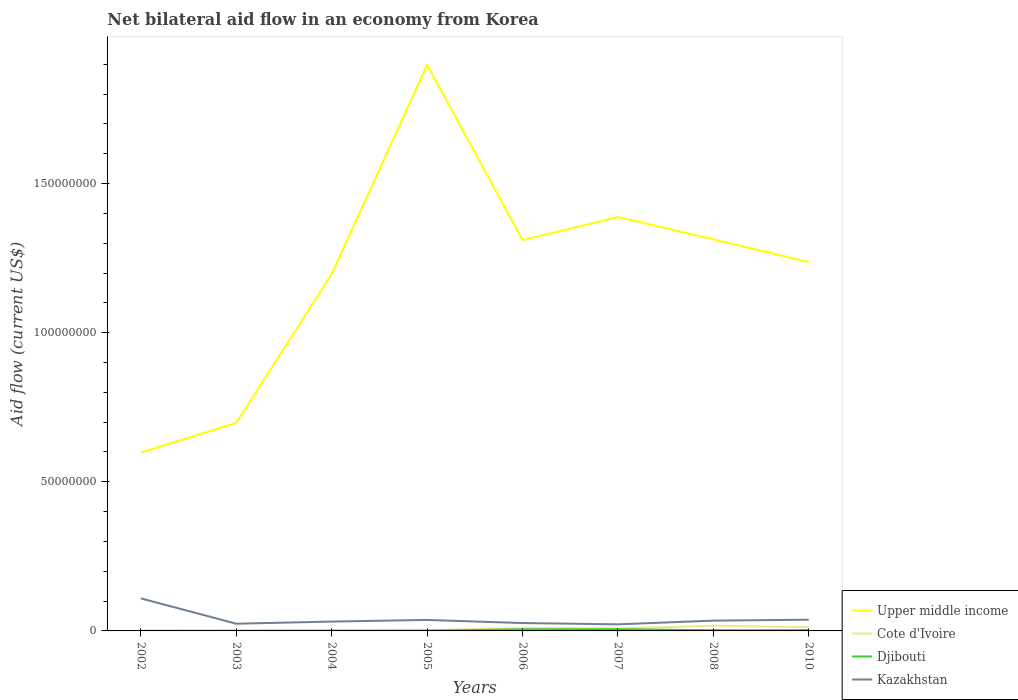Is the number of lines equal to the number of legend labels?
Make the answer very short. Yes. Across all years, what is the maximum net bilateral aid flow in Kazakhstan?
Your answer should be compact. 2.21e+06. In which year was the net bilateral aid flow in Djibouti maximum?
Provide a short and direct response. 2002. What is the total net bilateral aid flow in Djibouti in the graph?
Your answer should be compact. -4.30e+05. What is the difference between the highest and the second highest net bilateral aid flow in Cote d'Ivoire?
Ensure brevity in your answer.  1.72e+06. How many lines are there?
Your answer should be compact. 4. Does the graph contain any zero values?
Offer a very short reply. No. How many legend labels are there?
Provide a succinct answer. 4. How are the legend labels stacked?
Ensure brevity in your answer.  Vertical. What is the title of the graph?
Your answer should be compact. Net bilateral aid flow in an economy from Korea. Does "Isle of Man" appear as one of the legend labels in the graph?
Provide a succinct answer. No. What is the label or title of the Y-axis?
Your answer should be very brief. Aid flow (current US$). What is the Aid flow (current US$) in Upper middle income in 2002?
Keep it short and to the point. 5.98e+07. What is the Aid flow (current US$) of Djibouti in 2002?
Offer a terse response. 4.00e+04. What is the Aid flow (current US$) in Kazakhstan in 2002?
Ensure brevity in your answer.  1.09e+07. What is the Aid flow (current US$) of Upper middle income in 2003?
Give a very brief answer. 6.98e+07. What is the Aid flow (current US$) of Cote d'Ivoire in 2003?
Ensure brevity in your answer.  1.30e+05. What is the Aid flow (current US$) in Kazakhstan in 2003?
Make the answer very short. 2.42e+06. What is the Aid flow (current US$) in Upper middle income in 2004?
Make the answer very short. 1.20e+08. What is the Aid flow (current US$) of Djibouti in 2004?
Provide a short and direct response. 9.00e+04. What is the Aid flow (current US$) in Kazakhstan in 2004?
Your answer should be very brief. 3.13e+06. What is the Aid flow (current US$) of Upper middle income in 2005?
Your answer should be compact. 1.90e+08. What is the Aid flow (current US$) in Kazakhstan in 2005?
Provide a succinct answer. 3.68e+06. What is the Aid flow (current US$) of Upper middle income in 2006?
Your answer should be compact. 1.31e+08. What is the Aid flow (current US$) of Cote d'Ivoire in 2006?
Make the answer very short. 1.03e+06. What is the Aid flow (current US$) in Djibouti in 2006?
Your response must be concise. 5.30e+05. What is the Aid flow (current US$) in Kazakhstan in 2006?
Make the answer very short. 2.64e+06. What is the Aid flow (current US$) of Upper middle income in 2007?
Make the answer very short. 1.39e+08. What is the Aid flow (current US$) in Cote d'Ivoire in 2007?
Provide a short and direct response. 8.50e+05. What is the Aid flow (current US$) of Djibouti in 2007?
Keep it short and to the point. 5.70e+05. What is the Aid flow (current US$) in Kazakhstan in 2007?
Make the answer very short. 2.21e+06. What is the Aid flow (current US$) in Upper middle income in 2008?
Make the answer very short. 1.31e+08. What is the Aid flow (current US$) in Cote d'Ivoire in 2008?
Your answer should be very brief. 1.73e+06. What is the Aid flow (current US$) of Djibouti in 2008?
Your answer should be compact. 2.50e+05. What is the Aid flow (current US$) of Kazakhstan in 2008?
Keep it short and to the point. 3.45e+06. What is the Aid flow (current US$) of Upper middle income in 2010?
Your answer should be very brief. 1.24e+08. What is the Aid flow (current US$) in Cote d'Ivoire in 2010?
Offer a very short reply. 1.23e+06. What is the Aid flow (current US$) in Kazakhstan in 2010?
Offer a very short reply. 3.76e+06. Across all years, what is the maximum Aid flow (current US$) of Upper middle income?
Your response must be concise. 1.90e+08. Across all years, what is the maximum Aid flow (current US$) of Cote d'Ivoire?
Offer a very short reply. 1.73e+06. Across all years, what is the maximum Aid flow (current US$) in Djibouti?
Provide a succinct answer. 5.70e+05. Across all years, what is the maximum Aid flow (current US$) of Kazakhstan?
Offer a very short reply. 1.09e+07. Across all years, what is the minimum Aid flow (current US$) of Upper middle income?
Provide a succinct answer. 5.98e+07. Across all years, what is the minimum Aid flow (current US$) of Cote d'Ivoire?
Offer a very short reply. 10000. Across all years, what is the minimum Aid flow (current US$) of Djibouti?
Your answer should be very brief. 4.00e+04. Across all years, what is the minimum Aid flow (current US$) of Kazakhstan?
Make the answer very short. 2.21e+06. What is the total Aid flow (current US$) of Upper middle income in the graph?
Make the answer very short. 9.64e+08. What is the total Aid flow (current US$) in Cote d'Ivoire in the graph?
Your answer should be compact. 5.43e+06. What is the total Aid flow (current US$) of Djibouti in the graph?
Keep it short and to the point. 1.89e+06. What is the total Aid flow (current US$) in Kazakhstan in the graph?
Provide a succinct answer. 3.22e+07. What is the difference between the Aid flow (current US$) in Upper middle income in 2002 and that in 2003?
Your answer should be compact. -9.94e+06. What is the difference between the Aid flow (current US$) in Cote d'Ivoire in 2002 and that in 2003?
Make the answer very short. -1.20e+05. What is the difference between the Aid flow (current US$) of Djibouti in 2002 and that in 2003?
Keep it short and to the point. 0. What is the difference between the Aid flow (current US$) of Kazakhstan in 2002 and that in 2003?
Offer a very short reply. 8.49e+06. What is the difference between the Aid flow (current US$) of Upper middle income in 2002 and that in 2004?
Offer a very short reply. -5.99e+07. What is the difference between the Aid flow (current US$) of Djibouti in 2002 and that in 2004?
Your answer should be compact. -5.00e+04. What is the difference between the Aid flow (current US$) of Kazakhstan in 2002 and that in 2004?
Give a very brief answer. 7.78e+06. What is the difference between the Aid flow (current US$) in Upper middle income in 2002 and that in 2005?
Your response must be concise. -1.30e+08. What is the difference between the Aid flow (current US$) in Cote d'Ivoire in 2002 and that in 2005?
Offer a very short reply. -2.50e+05. What is the difference between the Aid flow (current US$) of Kazakhstan in 2002 and that in 2005?
Give a very brief answer. 7.23e+06. What is the difference between the Aid flow (current US$) of Upper middle income in 2002 and that in 2006?
Your answer should be very brief. -7.12e+07. What is the difference between the Aid flow (current US$) in Cote d'Ivoire in 2002 and that in 2006?
Your answer should be very brief. -1.02e+06. What is the difference between the Aid flow (current US$) of Djibouti in 2002 and that in 2006?
Offer a terse response. -4.90e+05. What is the difference between the Aid flow (current US$) in Kazakhstan in 2002 and that in 2006?
Ensure brevity in your answer.  8.27e+06. What is the difference between the Aid flow (current US$) in Upper middle income in 2002 and that in 2007?
Your response must be concise. -7.90e+07. What is the difference between the Aid flow (current US$) in Cote d'Ivoire in 2002 and that in 2007?
Give a very brief answer. -8.40e+05. What is the difference between the Aid flow (current US$) of Djibouti in 2002 and that in 2007?
Provide a succinct answer. -5.30e+05. What is the difference between the Aid flow (current US$) of Kazakhstan in 2002 and that in 2007?
Ensure brevity in your answer.  8.70e+06. What is the difference between the Aid flow (current US$) in Upper middle income in 2002 and that in 2008?
Provide a succinct answer. -7.15e+07. What is the difference between the Aid flow (current US$) of Cote d'Ivoire in 2002 and that in 2008?
Make the answer very short. -1.72e+06. What is the difference between the Aid flow (current US$) of Kazakhstan in 2002 and that in 2008?
Give a very brief answer. 7.46e+06. What is the difference between the Aid flow (current US$) of Upper middle income in 2002 and that in 2010?
Your answer should be very brief. -6.38e+07. What is the difference between the Aid flow (current US$) of Cote d'Ivoire in 2002 and that in 2010?
Offer a terse response. -1.22e+06. What is the difference between the Aid flow (current US$) in Kazakhstan in 2002 and that in 2010?
Provide a short and direct response. 7.15e+06. What is the difference between the Aid flow (current US$) in Upper middle income in 2003 and that in 2004?
Offer a terse response. -4.99e+07. What is the difference between the Aid flow (current US$) of Djibouti in 2003 and that in 2004?
Your answer should be very brief. -5.00e+04. What is the difference between the Aid flow (current US$) in Kazakhstan in 2003 and that in 2004?
Give a very brief answer. -7.10e+05. What is the difference between the Aid flow (current US$) of Upper middle income in 2003 and that in 2005?
Make the answer very short. -1.20e+08. What is the difference between the Aid flow (current US$) of Cote d'Ivoire in 2003 and that in 2005?
Provide a succinct answer. -1.30e+05. What is the difference between the Aid flow (current US$) of Kazakhstan in 2003 and that in 2005?
Keep it short and to the point. -1.26e+06. What is the difference between the Aid flow (current US$) of Upper middle income in 2003 and that in 2006?
Offer a very short reply. -6.13e+07. What is the difference between the Aid flow (current US$) of Cote d'Ivoire in 2003 and that in 2006?
Your answer should be very brief. -9.00e+05. What is the difference between the Aid flow (current US$) in Djibouti in 2003 and that in 2006?
Provide a succinct answer. -4.90e+05. What is the difference between the Aid flow (current US$) in Kazakhstan in 2003 and that in 2006?
Your answer should be very brief. -2.20e+05. What is the difference between the Aid flow (current US$) of Upper middle income in 2003 and that in 2007?
Your answer should be very brief. -6.90e+07. What is the difference between the Aid flow (current US$) in Cote d'Ivoire in 2003 and that in 2007?
Provide a succinct answer. -7.20e+05. What is the difference between the Aid flow (current US$) of Djibouti in 2003 and that in 2007?
Ensure brevity in your answer.  -5.30e+05. What is the difference between the Aid flow (current US$) of Kazakhstan in 2003 and that in 2007?
Offer a very short reply. 2.10e+05. What is the difference between the Aid flow (current US$) in Upper middle income in 2003 and that in 2008?
Ensure brevity in your answer.  -6.15e+07. What is the difference between the Aid flow (current US$) in Cote d'Ivoire in 2003 and that in 2008?
Make the answer very short. -1.60e+06. What is the difference between the Aid flow (current US$) of Djibouti in 2003 and that in 2008?
Your response must be concise. -2.10e+05. What is the difference between the Aid flow (current US$) in Kazakhstan in 2003 and that in 2008?
Provide a succinct answer. -1.03e+06. What is the difference between the Aid flow (current US$) in Upper middle income in 2003 and that in 2010?
Offer a terse response. -5.39e+07. What is the difference between the Aid flow (current US$) in Cote d'Ivoire in 2003 and that in 2010?
Your answer should be very brief. -1.10e+06. What is the difference between the Aid flow (current US$) of Kazakhstan in 2003 and that in 2010?
Provide a short and direct response. -1.34e+06. What is the difference between the Aid flow (current US$) of Upper middle income in 2004 and that in 2005?
Your response must be concise. -7.01e+07. What is the difference between the Aid flow (current US$) in Cote d'Ivoire in 2004 and that in 2005?
Your answer should be compact. -7.00e+04. What is the difference between the Aid flow (current US$) of Kazakhstan in 2004 and that in 2005?
Offer a terse response. -5.50e+05. What is the difference between the Aid flow (current US$) in Upper middle income in 2004 and that in 2006?
Keep it short and to the point. -1.14e+07. What is the difference between the Aid flow (current US$) in Cote d'Ivoire in 2004 and that in 2006?
Offer a very short reply. -8.40e+05. What is the difference between the Aid flow (current US$) in Djibouti in 2004 and that in 2006?
Offer a terse response. -4.40e+05. What is the difference between the Aid flow (current US$) of Kazakhstan in 2004 and that in 2006?
Your response must be concise. 4.90e+05. What is the difference between the Aid flow (current US$) of Upper middle income in 2004 and that in 2007?
Keep it short and to the point. -1.91e+07. What is the difference between the Aid flow (current US$) of Cote d'Ivoire in 2004 and that in 2007?
Keep it short and to the point. -6.60e+05. What is the difference between the Aid flow (current US$) of Djibouti in 2004 and that in 2007?
Your answer should be compact. -4.80e+05. What is the difference between the Aid flow (current US$) of Kazakhstan in 2004 and that in 2007?
Your answer should be very brief. 9.20e+05. What is the difference between the Aid flow (current US$) in Upper middle income in 2004 and that in 2008?
Offer a terse response. -1.16e+07. What is the difference between the Aid flow (current US$) of Cote d'Ivoire in 2004 and that in 2008?
Provide a short and direct response. -1.54e+06. What is the difference between the Aid flow (current US$) in Kazakhstan in 2004 and that in 2008?
Make the answer very short. -3.20e+05. What is the difference between the Aid flow (current US$) in Upper middle income in 2004 and that in 2010?
Your answer should be compact. -3.97e+06. What is the difference between the Aid flow (current US$) of Cote d'Ivoire in 2004 and that in 2010?
Your response must be concise. -1.04e+06. What is the difference between the Aid flow (current US$) of Djibouti in 2004 and that in 2010?
Your response must be concise. -1.80e+05. What is the difference between the Aid flow (current US$) in Kazakhstan in 2004 and that in 2010?
Your answer should be very brief. -6.30e+05. What is the difference between the Aid flow (current US$) of Upper middle income in 2005 and that in 2006?
Ensure brevity in your answer.  5.87e+07. What is the difference between the Aid flow (current US$) of Cote d'Ivoire in 2005 and that in 2006?
Your answer should be compact. -7.70e+05. What is the difference between the Aid flow (current US$) in Djibouti in 2005 and that in 2006?
Offer a terse response. -4.30e+05. What is the difference between the Aid flow (current US$) of Kazakhstan in 2005 and that in 2006?
Provide a short and direct response. 1.04e+06. What is the difference between the Aid flow (current US$) in Upper middle income in 2005 and that in 2007?
Provide a succinct answer. 5.10e+07. What is the difference between the Aid flow (current US$) in Cote d'Ivoire in 2005 and that in 2007?
Ensure brevity in your answer.  -5.90e+05. What is the difference between the Aid flow (current US$) of Djibouti in 2005 and that in 2007?
Your answer should be very brief. -4.70e+05. What is the difference between the Aid flow (current US$) in Kazakhstan in 2005 and that in 2007?
Your response must be concise. 1.47e+06. What is the difference between the Aid flow (current US$) in Upper middle income in 2005 and that in 2008?
Offer a very short reply. 5.85e+07. What is the difference between the Aid flow (current US$) in Cote d'Ivoire in 2005 and that in 2008?
Ensure brevity in your answer.  -1.47e+06. What is the difference between the Aid flow (current US$) of Djibouti in 2005 and that in 2008?
Ensure brevity in your answer.  -1.50e+05. What is the difference between the Aid flow (current US$) in Upper middle income in 2005 and that in 2010?
Give a very brief answer. 6.61e+07. What is the difference between the Aid flow (current US$) in Cote d'Ivoire in 2005 and that in 2010?
Ensure brevity in your answer.  -9.70e+05. What is the difference between the Aid flow (current US$) of Djibouti in 2005 and that in 2010?
Offer a terse response. -1.70e+05. What is the difference between the Aid flow (current US$) in Upper middle income in 2006 and that in 2007?
Your response must be concise. -7.73e+06. What is the difference between the Aid flow (current US$) in Cote d'Ivoire in 2006 and that in 2007?
Offer a terse response. 1.80e+05. What is the difference between the Aid flow (current US$) of Djibouti in 2006 and that in 2007?
Offer a terse response. -4.00e+04. What is the difference between the Aid flow (current US$) of Kazakhstan in 2006 and that in 2007?
Provide a short and direct response. 4.30e+05. What is the difference between the Aid flow (current US$) in Cote d'Ivoire in 2006 and that in 2008?
Offer a terse response. -7.00e+05. What is the difference between the Aid flow (current US$) in Kazakhstan in 2006 and that in 2008?
Give a very brief answer. -8.10e+05. What is the difference between the Aid flow (current US$) of Upper middle income in 2006 and that in 2010?
Give a very brief answer. 7.40e+06. What is the difference between the Aid flow (current US$) of Djibouti in 2006 and that in 2010?
Offer a very short reply. 2.60e+05. What is the difference between the Aid flow (current US$) of Kazakhstan in 2006 and that in 2010?
Make the answer very short. -1.12e+06. What is the difference between the Aid flow (current US$) of Upper middle income in 2007 and that in 2008?
Give a very brief answer. 7.50e+06. What is the difference between the Aid flow (current US$) in Cote d'Ivoire in 2007 and that in 2008?
Keep it short and to the point. -8.80e+05. What is the difference between the Aid flow (current US$) in Djibouti in 2007 and that in 2008?
Offer a terse response. 3.20e+05. What is the difference between the Aid flow (current US$) of Kazakhstan in 2007 and that in 2008?
Offer a very short reply. -1.24e+06. What is the difference between the Aid flow (current US$) in Upper middle income in 2007 and that in 2010?
Ensure brevity in your answer.  1.51e+07. What is the difference between the Aid flow (current US$) in Cote d'Ivoire in 2007 and that in 2010?
Keep it short and to the point. -3.80e+05. What is the difference between the Aid flow (current US$) of Djibouti in 2007 and that in 2010?
Give a very brief answer. 3.00e+05. What is the difference between the Aid flow (current US$) in Kazakhstan in 2007 and that in 2010?
Ensure brevity in your answer.  -1.55e+06. What is the difference between the Aid flow (current US$) in Upper middle income in 2008 and that in 2010?
Provide a succinct answer. 7.63e+06. What is the difference between the Aid flow (current US$) in Cote d'Ivoire in 2008 and that in 2010?
Make the answer very short. 5.00e+05. What is the difference between the Aid flow (current US$) in Kazakhstan in 2008 and that in 2010?
Provide a succinct answer. -3.10e+05. What is the difference between the Aid flow (current US$) of Upper middle income in 2002 and the Aid flow (current US$) of Cote d'Ivoire in 2003?
Ensure brevity in your answer.  5.97e+07. What is the difference between the Aid flow (current US$) of Upper middle income in 2002 and the Aid flow (current US$) of Djibouti in 2003?
Keep it short and to the point. 5.98e+07. What is the difference between the Aid flow (current US$) of Upper middle income in 2002 and the Aid flow (current US$) of Kazakhstan in 2003?
Make the answer very short. 5.74e+07. What is the difference between the Aid flow (current US$) of Cote d'Ivoire in 2002 and the Aid flow (current US$) of Kazakhstan in 2003?
Offer a very short reply. -2.41e+06. What is the difference between the Aid flow (current US$) in Djibouti in 2002 and the Aid flow (current US$) in Kazakhstan in 2003?
Make the answer very short. -2.38e+06. What is the difference between the Aid flow (current US$) of Upper middle income in 2002 and the Aid flow (current US$) of Cote d'Ivoire in 2004?
Provide a short and direct response. 5.96e+07. What is the difference between the Aid flow (current US$) of Upper middle income in 2002 and the Aid flow (current US$) of Djibouti in 2004?
Provide a short and direct response. 5.97e+07. What is the difference between the Aid flow (current US$) in Upper middle income in 2002 and the Aid flow (current US$) in Kazakhstan in 2004?
Give a very brief answer. 5.67e+07. What is the difference between the Aid flow (current US$) in Cote d'Ivoire in 2002 and the Aid flow (current US$) in Kazakhstan in 2004?
Give a very brief answer. -3.12e+06. What is the difference between the Aid flow (current US$) of Djibouti in 2002 and the Aid flow (current US$) of Kazakhstan in 2004?
Ensure brevity in your answer.  -3.09e+06. What is the difference between the Aid flow (current US$) of Upper middle income in 2002 and the Aid flow (current US$) of Cote d'Ivoire in 2005?
Provide a succinct answer. 5.96e+07. What is the difference between the Aid flow (current US$) in Upper middle income in 2002 and the Aid flow (current US$) in Djibouti in 2005?
Give a very brief answer. 5.97e+07. What is the difference between the Aid flow (current US$) of Upper middle income in 2002 and the Aid flow (current US$) of Kazakhstan in 2005?
Keep it short and to the point. 5.61e+07. What is the difference between the Aid flow (current US$) in Cote d'Ivoire in 2002 and the Aid flow (current US$) in Kazakhstan in 2005?
Give a very brief answer. -3.67e+06. What is the difference between the Aid flow (current US$) in Djibouti in 2002 and the Aid flow (current US$) in Kazakhstan in 2005?
Keep it short and to the point. -3.64e+06. What is the difference between the Aid flow (current US$) of Upper middle income in 2002 and the Aid flow (current US$) of Cote d'Ivoire in 2006?
Provide a succinct answer. 5.88e+07. What is the difference between the Aid flow (current US$) of Upper middle income in 2002 and the Aid flow (current US$) of Djibouti in 2006?
Ensure brevity in your answer.  5.93e+07. What is the difference between the Aid flow (current US$) in Upper middle income in 2002 and the Aid flow (current US$) in Kazakhstan in 2006?
Your answer should be compact. 5.72e+07. What is the difference between the Aid flow (current US$) in Cote d'Ivoire in 2002 and the Aid flow (current US$) in Djibouti in 2006?
Give a very brief answer. -5.20e+05. What is the difference between the Aid flow (current US$) in Cote d'Ivoire in 2002 and the Aid flow (current US$) in Kazakhstan in 2006?
Provide a succinct answer. -2.63e+06. What is the difference between the Aid flow (current US$) of Djibouti in 2002 and the Aid flow (current US$) of Kazakhstan in 2006?
Your response must be concise. -2.60e+06. What is the difference between the Aid flow (current US$) of Upper middle income in 2002 and the Aid flow (current US$) of Cote d'Ivoire in 2007?
Your response must be concise. 5.90e+07. What is the difference between the Aid flow (current US$) in Upper middle income in 2002 and the Aid flow (current US$) in Djibouti in 2007?
Make the answer very short. 5.92e+07. What is the difference between the Aid flow (current US$) in Upper middle income in 2002 and the Aid flow (current US$) in Kazakhstan in 2007?
Offer a very short reply. 5.76e+07. What is the difference between the Aid flow (current US$) in Cote d'Ivoire in 2002 and the Aid flow (current US$) in Djibouti in 2007?
Your answer should be compact. -5.60e+05. What is the difference between the Aid flow (current US$) of Cote d'Ivoire in 2002 and the Aid flow (current US$) of Kazakhstan in 2007?
Provide a short and direct response. -2.20e+06. What is the difference between the Aid flow (current US$) of Djibouti in 2002 and the Aid flow (current US$) of Kazakhstan in 2007?
Your answer should be very brief. -2.17e+06. What is the difference between the Aid flow (current US$) of Upper middle income in 2002 and the Aid flow (current US$) of Cote d'Ivoire in 2008?
Ensure brevity in your answer.  5.81e+07. What is the difference between the Aid flow (current US$) of Upper middle income in 2002 and the Aid flow (current US$) of Djibouti in 2008?
Make the answer very short. 5.96e+07. What is the difference between the Aid flow (current US$) of Upper middle income in 2002 and the Aid flow (current US$) of Kazakhstan in 2008?
Your response must be concise. 5.64e+07. What is the difference between the Aid flow (current US$) in Cote d'Ivoire in 2002 and the Aid flow (current US$) in Kazakhstan in 2008?
Offer a very short reply. -3.44e+06. What is the difference between the Aid flow (current US$) of Djibouti in 2002 and the Aid flow (current US$) of Kazakhstan in 2008?
Your answer should be compact. -3.41e+06. What is the difference between the Aid flow (current US$) in Upper middle income in 2002 and the Aid flow (current US$) in Cote d'Ivoire in 2010?
Make the answer very short. 5.86e+07. What is the difference between the Aid flow (current US$) of Upper middle income in 2002 and the Aid flow (current US$) of Djibouti in 2010?
Your answer should be very brief. 5.96e+07. What is the difference between the Aid flow (current US$) of Upper middle income in 2002 and the Aid flow (current US$) of Kazakhstan in 2010?
Ensure brevity in your answer.  5.61e+07. What is the difference between the Aid flow (current US$) in Cote d'Ivoire in 2002 and the Aid flow (current US$) in Djibouti in 2010?
Give a very brief answer. -2.60e+05. What is the difference between the Aid flow (current US$) in Cote d'Ivoire in 2002 and the Aid flow (current US$) in Kazakhstan in 2010?
Provide a succinct answer. -3.75e+06. What is the difference between the Aid flow (current US$) of Djibouti in 2002 and the Aid flow (current US$) of Kazakhstan in 2010?
Offer a very short reply. -3.72e+06. What is the difference between the Aid flow (current US$) of Upper middle income in 2003 and the Aid flow (current US$) of Cote d'Ivoire in 2004?
Your answer should be compact. 6.96e+07. What is the difference between the Aid flow (current US$) of Upper middle income in 2003 and the Aid flow (current US$) of Djibouti in 2004?
Your response must be concise. 6.97e+07. What is the difference between the Aid flow (current US$) of Upper middle income in 2003 and the Aid flow (current US$) of Kazakhstan in 2004?
Make the answer very short. 6.66e+07. What is the difference between the Aid flow (current US$) of Cote d'Ivoire in 2003 and the Aid flow (current US$) of Djibouti in 2004?
Your answer should be compact. 4.00e+04. What is the difference between the Aid flow (current US$) in Djibouti in 2003 and the Aid flow (current US$) in Kazakhstan in 2004?
Provide a short and direct response. -3.09e+06. What is the difference between the Aid flow (current US$) of Upper middle income in 2003 and the Aid flow (current US$) of Cote d'Ivoire in 2005?
Provide a succinct answer. 6.95e+07. What is the difference between the Aid flow (current US$) of Upper middle income in 2003 and the Aid flow (current US$) of Djibouti in 2005?
Keep it short and to the point. 6.97e+07. What is the difference between the Aid flow (current US$) in Upper middle income in 2003 and the Aid flow (current US$) in Kazakhstan in 2005?
Give a very brief answer. 6.61e+07. What is the difference between the Aid flow (current US$) of Cote d'Ivoire in 2003 and the Aid flow (current US$) of Djibouti in 2005?
Your response must be concise. 3.00e+04. What is the difference between the Aid flow (current US$) in Cote d'Ivoire in 2003 and the Aid flow (current US$) in Kazakhstan in 2005?
Your response must be concise. -3.55e+06. What is the difference between the Aid flow (current US$) of Djibouti in 2003 and the Aid flow (current US$) of Kazakhstan in 2005?
Provide a short and direct response. -3.64e+06. What is the difference between the Aid flow (current US$) in Upper middle income in 2003 and the Aid flow (current US$) in Cote d'Ivoire in 2006?
Give a very brief answer. 6.87e+07. What is the difference between the Aid flow (current US$) of Upper middle income in 2003 and the Aid flow (current US$) of Djibouti in 2006?
Offer a terse response. 6.92e+07. What is the difference between the Aid flow (current US$) in Upper middle income in 2003 and the Aid flow (current US$) in Kazakhstan in 2006?
Your response must be concise. 6.71e+07. What is the difference between the Aid flow (current US$) of Cote d'Ivoire in 2003 and the Aid flow (current US$) of Djibouti in 2006?
Provide a short and direct response. -4.00e+05. What is the difference between the Aid flow (current US$) of Cote d'Ivoire in 2003 and the Aid flow (current US$) of Kazakhstan in 2006?
Offer a terse response. -2.51e+06. What is the difference between the Aid flow (current US$) of Djibouti in 2003 and the Aid flow (current US$) of Kazakhstan in 2006?
Provide a short and direct response. -2.60e+06. What is the difference between the Aid flow (current US$) in Upper middle income in 2003 and the Aid flow (current US$) in Cote d'Ivoire in 2007?
Your answer should be compact. 6.89e+07. What is the difference between the Aid flow (current US$) of Upper middle income in 2003 and the Aid flow (current US$) of Djibouti in 2007?
Ensure brevity in your answer.  6.92e+07. What is the difference between the Aid flow (current US$) in Upper middle income in 2003 and the Aid flow (current US$) in Kazakhstan in 2007?
Your answer should be very brief. 6.76e+07. What is the difference between the Aid flow (current US$) of Cote d'Ivoire in 2003 and the Aid flow (current US$) of Djibouti in 2007?
Make the answer very short. -4.40e+05. What is the difference between the Aid flow (current US$) in Cote d'Ivoire in 2003 and the Aid flow (current US$) in Kazakhstan in 2007?
Offer a very short reply. -2.08e+06. What is the difference between the Aid flow (current US$) in Djibouti in 2003 and the Aid flow (current US$) in Kazakhstan in 2007?
Your response must be concise. -2.17e+06. What is the difference between the Aid flow (current US$) of Upper middle income in 2003 and the Aid flow (current US$) of Cote d'Ivoire in 2008?
Provide a short and direct response. 6.80e+07. What is the difference between the Aid flow (current US$) in Upper middle income in 2003 and the Aid flow (current US$) in Djibouti in 2008?
Your answer should be compact. 6.95e+07. What is the difference between the Aid flow (current US$) in Upper middle income in 2003 and the Aid flow (current US$) in Kazakhstan in 2008?
Offer a very short reply. 6.63e+07. What is the difference between the Aid flow (current US$) of Cote d'Ivoire in 2003 and the Aid flow (current US$) of Kazakhstan in 2008?
Your answer should be compact. -3.32e+06. What is the difference between the Aid flow (current US$) in Djibouti in 2003 and the Aid flow (current US$) in Kazakhstan in 2008?
Ensure brevity in your answer.  -3.41e+06. What is the difference between the Aid flow (current US$) of Upper middle income in 2003 and the Aid flow (current US$) of Cote d'Ivoire in 2010?
Provide a short and direct response. 6.85e+07. What is the difference between the Aid flow (current US$) in Upper middle income in 2003 and the Aid flow (current US$) in Djibouti in 2010?
Keep it short and to the point. 6.95e+07. What is the difference between the Aid flow (current US$) of Upper middle income in 2003 and the Aid flow (current US$) of Kazakhstan in 2010?
Offer a very short reply. 6.60e+07. What is the difference between the Aid flow (current US$) of Cote d'Ivoire in 2003 and the Aid flow (current US$) of Djibouti in 2010?
Your answer should be compact. -1.40e+05. What is the difference between the Aid flow (current US$) of Cote d'Ivoire in 2003 and the Aid flow (current US$) of Kazakhstan in 2010?
Ensure brevity in your answer.  -3.63e+06. What is the difference between the Aid flow (current US$) of Djibouti in 2003 and the Aid flow (current US$) of Kazakhstan in 2010?
Your answer should be very brief. -3.72e+06. What is the difference between the Aid flow (current US$) in Upper middle income in 2004 and the Aid flow (current US$) in Cote d'Ivoire in 2005?
Ensure brevity in your answer.  1.19e+08. What is the difference between the Aid flow (current US$) in Upper middle income in 2004 and the Aid flow (current US$) in Djibouti in 2005?
Provide a short and direct response. 1.20e+08. What is the difference between the Aid flow (current US$) of Upper middle income in 2004 and the Aid flow (current US$) of Kazakhstan in 2005?
Provide a succinct answer. 1.16e+08. What is the difference between the Aid flow (current US$) in Cote d'Ivoire in 2004 and the Aid flow (current US$) in Kazakhstan in 2005?
Provide a short and direct response. -3.49e+06. What is the difference between the Aid flow (current US$) of Djibouti in 2004 and the Aid flow (current US$) of Kazakhstan in 2005?
Make the answer very short. -3.59e+06. What is the difference between the Aid flow (current US$) in Upper middle income in 2004 and the Aid flow (current US$) in Cote d'Ivoire in 2006?
Give a very brief answer. 1.19e+08. What is the difference between the Aid flow (current US$) of Upper middle income in 2004 and the Aid flow (current US$) of Djibouti in 2006?
Your response must be concise. 1.19e+08. What is the difference between the Aid flow (current US$) of Upper middle income in 2004 and the Aid flow (current US$) of Kazakhstan in 2006?
Provide a succinct answer. 1.17e+08. What is the difference between the Aid flow (current US$) of Cote d'Ivoire in 2004 and the Aid flow (current US$) of Kazakhstan in 2006?
Make the answer very short. -2.45e+06. What is the difference between the Aid flow (current US$) in Djibouti in 2004 and the Aid flow (current US$) in Kazakhstan in 2006?
Make the answer very short. -2.55e+06. What is the difference between the Aid flow (current US$) in Upper middle income in 2004 and the Aid flow (current US$) in Cote d'Ivoire in 2007?
Give a very brief answer. 1.19e+08. What is the difference between the Aid flow (current US$) in Upper middle income in 2004 and the Aid flow (current US$) in Djibouti in 2007?
Provide a succinct answer. 1.19e+08. What is the difference between the Aid flow (current US$) of Upper middle income in 2004 and the Aid flow (current US$) of Kazakhstan in 2007?
Your answer should be compact. 1.17e+08. What is the difference between the Aid flow (current US$) in Cote d'Ivoire in 2004 and the Aid flow (current US$) in Djibouti in 2007?
Give a very brief answer. -3.80e+05. What is the difference between the Aid flow (current US$) of Cote d'Ivoire in 2004 and the Aid flow (current US$) of Kazakhstan in 2007?
Offer a terse response. -2.02e+06. What is the difference between the Aid flow (current US$) of Djibouti in 2004 and the Aid flow (current US$) of Kazakhstan in 2007?
Offer a very short reply. -2.12e+06. What is the difference between the Aid flow (current US$) in Upper middle income in 2004 and the Aid flow (current US$) in Cote d'Ivoire in 2008?
Your answer should be very brief. 1.18e+08. What is the difference between the Aid flow (current US$) of Upper middle income in 2004 and the Aid flow (current US$) of Djibouti in 2008?
Offer a very short reply. 1.19e+08. What is the difference between the Aid flow (current US$) of Upper middle income in 2004 and the Aid flow (current US$) of Kazakhstan in 2008?
Your answer should be compact. 1.16e+08. What is the difference between the Aid flow (current US$) in Cote d'Ivoire in 2004 and the Aid flow (current US$) in Djibouti in 2008?
Offer a very short reply. -6.00e+04. What is the difference between the Aid flow (current US$) in Cote d'Ivoire in 2004 and the Aid flow (current US$) in Kazakhstan in 2008?
Your answer should be compact. -3.26e+06. What is the difference between the Aid flow (current US$) in Djibouti in 2004 and the Aid flow (current US$) in Kazakhstan in 2008?
Offer a very short reply. -3.36e+06. What is the difference between the Aid flow (current US$) of Upper middle income in 2004 and the Aid flow (current US$) of Cote d'Ivoire in 2010?
Give a very brief answer. 1.18e+08. What is the difference between the Aid flow (current US$) of Upper middle income in 2004 and the Aid flow (current US$) of Djibouti in 2010?
Your answer should be very brief. 1.19e+08. What is the difference between the Aid flow (current US$) in Upper middle income in 2004 and the Aid flow (current US$) in Kazakhstan in 2010?
Your answer should be compact. 1.16e+08. What is the difference between the Aid flow (current US$) in Cote d'Ivoire in 2004 and the Aid flow (current US$) in Kazakhstan in 2010?
Your response must be concise. -3.57e+06. What is the difference between the Aid flow (current US$) of Djibouti in 2004 and the Aid flow (current US$) of Kazakhstan in 2010?
Keep it short and to the point. -3.67e+06. What is the difference between the Aid flow (current US$) of Upper middle income in 2005 and the Aid flow (current US$) of Cote d'Ivoire in 2006?
Your response must be concise. 1.89e+08. What is the difference between the Aid flow (current US$) in Upper middle income in 2005 and the Aid flow (current US$) in Djibouti in 2006?
Provide a succinct answer. 1.89e+08. What is the difference between the Aid flow (current US$) of Upper middle income in 2005 and the Aid flow (current US$) of Kazakhstan in 2006?
Provide a short and direct response. 1.87e+08. What is the difference between the Aid flow (current US$) of Cote d'Ivoire in 2005 and the Aid flow (current US$) of Kazakhstan in 2006?
Keep it short and to the point. -2.38e+06. What is the difference between the Aid flow (current US$) in Djibouti in 2005 and the Aid flow (current US$) in Kazakhstan in 2006?
Ensure brevity in your answer.  -2.54e+06. What is the difference between the Aid flow (current US$) in Upper middle income in 2005 and the Aid flow (current US$) in Cote d'Ivoire in 2007?
Ensure brevity in your answer.  1.89e+08. What is the difference between the Aid flow (current US$) in Upper middle income in 2005 and the Aid flow (current US$) in Djibouti in 2007?
Provide a short and direct response. 1.89e+08. What is the difference between the Aid flow (current US$) of Upper middle income in 2005 and the Aid flow (current US$) of Kazakhstan in 2007?
Provide a short and direct response. 1.88e+08. What is the difference between the Aid flow (current US$) in Cote d'Ivoire in 2005 and the Aid flow (current US$) in Djibouti in 2007?
Your response must be concise. -3.10e+05. What is the difference between the Aid flow (current US$) of Cote d'Ivoire in 2005 and the Aid flow (current US$) of Kazakhstan in 2007?
Ensure brevity in your answer.  -1.95e+06. What is the difference between the Aid flow (current US$) of Djibouti in 2005 and the Aid flow (current US$) of Kazakhstan in 2007?
Offer a terse response. -2.11e+06. What is the difference between the Aid flow (current US$) in Upper middle income in 2005 and the Aid flow (current US$) in Cote d'Ivoire in 2008?
Give a very brief answer. 1.88e+08. What is the difference between the Aid flow (current US$) of Upper middle income in 2005 and the Aid flow (current US$) of Djibouti in 2008?
Make the answer very short. 1.90e+08. What is the difference between the Aid flow (current US$) in Upper middle income in 2005 and the Aid flow (current US$) in Kazakhstan in 2008?
Make the answer very short. 1.86e+08. What is the difference between the Aid flow (current US$) of Cote d'Ivoire in 2005 and the Aid flow (current US$) of Djibouti in 2008?
Offer a very short reply. 10000. What is the difference between the Aid flow (current US$) in Cote d'Ivoire in 2005 and the Aid flow (current US$) in Kazakhstan in 2008?
Your response must be concise. -3.19e+06. What is the difference between the Aid flow (current US$) of Djibouti in 2005 and the Aid flow (current US$) of Kazakhstan in 2008?
Offer a terse response. -3.35e+06. What is the difference between the Aid flow (current US$) in Upper middle income in 2005 and the Aid flow (current US$) in Cote d'Ivoire in 2010?
Your answer should be compact. 1.89e+08. What is the difference between the Aid flow (current US$) of Upper middle income in 2005 and the Aid flow (current US$) of Djibouti in 2010?
Offer a very short reply. 1.90e+08. What is the difference between the Aid flow (current US$) in Upper middle income in 2005 and the Aid flow (current US$) in Kazakhstan in 2010?
Provide a succinct answer. 1.86e+08. What is the difference between the Aid flow (current US$) of Cote d'Ivoire in 2005 and the Aid flow (current US$) of Djibouti in 2010?
Your answer should be compact. -10000. What is the difference between the Aid flow (current US$) of Cote d'Ivoire in 2005 and the Aid flow (current US$) of Kazakhstan in 2010?
Your answer should be compact. -3.50e+06. What is the difference between the Aid flow (current US$) in Djibouti in 2005 and the Aid flow (current US$) in Kazakhstan in 2010?
Keep it short and to the point. -3.66e+06. What is the difference between the Aid flow (current US$) in Upper middle income in 2006 and the Aid flow (current US$) in Cote d'Ivoire in 2007?
Provide a succinct answer. 1.30e+08. What is the difference between the Aid flow (current US$) of Upper middle income in 2006 and the Aid flow (current US$) of Djibouti in 2007?
Provide a succinct answer. 1.30e+08. What is the difference between the Aid flow (current US$) in Upper middle income in 2006 and the Aid flow (current US$) in Kazakhstan in 2007?
Your answer should be compact. 1.29e+08. What is the difference between the Aid flow (current US$) in Cote d'Ivoire in 2006 and the Aid flow (current US$) in Djibouti in 2007?
Provide a short and direct response. 4.60e+05. What is the difference between the Aid flow (current US$) of Cote d'Ivoire in 2006 and the Aid flow (current US$) of Kazakhstan in 2007?
Offer a terse response. -1.18e+06. What is the difference between the Aid flow (current US$) of Djibouti in 2006 and the Aid flow (current US$) of Kazakhstan in 2007?
Make the answer very short. -1.68e+06. What is the difference between the Aid flow (current US$) in Upper middle income in 2006 and the Aid flow (current US$) in Cote d'Ivoire in 2008?
Provide a short and direct response. 1.29e+08. What is the difference between the Aid flow (current US$) in Upper middle income in 2006 and the Aid flow (current US$) in Djibouti in 2008?
Provide a succinct answer. 1.31e+08. What is the difference between the Aid flow (current US$) in Upper middle income in 2006 and the Aid flow (current US$) in Kazakhstan in 2008?
Provide a short and direct response. 1.28e+08. What is the difference between the Aid flow (current US$) of Cote d'Ivoire in 2006 and the Aid flow (current US$) of Djibouti in 2008?
Give a very brief answer. 7.80e+05. What is the difference between the Aid flow (current US$) in Cote d'Ivoire in 2006 and the Aid flow (current US$) in Kazakhstan in 2008?
Give a very brief answer. -2.42e+06. What is the difference between the Aid flow (current US$) of Djibouti in 2006 and the Aid flow (current US$) of Kazakhstan in 2008?
Provide a short and direct response. -2.92e+06. What is the difference between the Aid flow (current US$) in Upper middle income in 2006 and the Aid flow (current US$) in Cote d'Ivoire in 2010?
Your response must be concise. 1.30e+08. What is the difference between the Aid flow (current US$) in Upper middle income in 2006 and the Aid flow (current US$) in Djibouti in 2010?
Give a very brief answer. 1.31e+08. What is the difference between the Aid flow (current US$) of Upper middle income in 2006 and the Aid flow (current US$) of Kazakhstan in 2010?
Provide a succinct answer. 1.27e+08. What is the difference between the Aid flow (current US$) in Cote d'Ivoire in 2006 and the Aid flow (current US$) in Djibouti in 2010?
Ensure brevity in your answer.  7.60e+05. What is the difference between the Aid flow (current US$) in Cote d'Ivoire in 2006 and the Aid flow (current US$) in Kazakhstan in 2010?
Make the answer very short. -2.73e+06. What is the difference between the Aid flow (current US$) in Djibouti in 2006 and the Aid flow (current US$) in Kazakhstan in 2010?
Make the answer very short. -3.23e+06. What is the difference between the Aid flow (current US$) in Upper middle income in 2007 and the Aid flow (current US$) in Cote d'Ivoire in 2008?
Give a very brief answer. 1.37e+08. What is the difference between the Aid flow (current US$) of Upper middle income in 2007 and the Aid flow (current US$) of Djibouti in 2008?
Ensure brevity in your answer.  1.39e+08. What is the difference between the Aid flow (current US$) in Upper middle income in 2007 and the Aid flow (current US$) in Kazakhstan in 2008?
Your answer should be very brief. 1.35e+08. What is the difference between the Aid flow (current US$) in Cote d'Ivoire in 2007 and the Aid flow (current US$) in Kazakhstan in 2008?
Your answer should be very brief. -2.60e+06. What is the difference between the Aid flow (current US$) of Djibouti in 2007 and the Aid flow (current US$) of Kazakhstan in 2008?
Ensure brevity in your answer.  -2.88e+06. What is the difference between the Aid flow (current US$) of Upper middle income in 2007 and the Aid flow (current US$) of Cote d'Ivoire in 2010?
Keep it short and to the point. 1.38e+08. What is the difference between the Aid flow (current US$) of Upper middle income in 2007 and the Aid flow (current US$) of Djibouti in 2010?
Keep it short and to the point. 1.39e+08. What is the difference between the Aid flow (current US$) in Upper middle income in 2007 and the Aid flow (current US$) in Kazakhstan in 2010?
Your response must be concise. 1.35e+08. What is the difference between the Aid flow (current US$) in Cote d'Ivoire in 2007 and the Aid flow (current US$) in Djibouti in 2010?
Offer a terse response. 5.80e+05. What is the difference between the Aid flow (current US$) of Cote d'Ivoire in 2007 and the Aid flow (current US$) of Kazakhstan in 2010?
Give a very brief answer. -2.91e+06. What is the difference between the Aid flow (current US$) in Djibouti in 2007 and the Aid flow (current US$) in Kazakhstan in 2010?
Offer a very short reply. -3.19e+06. What is the difference between the Aid flow (current US$) of Upper middle income in 2008 and the Aid flow (current US$) of Cote d'Ivoire in 2010?
Your response must be concise. 1.30e+08. What is the difference between the Aid flow (current US$) in Upper middle income in 2008 and the Aid flow (current US$) in Djibouti in 2010?
Offer a terse response. 1.31e+08. What is the difference between the Aid flow (current US$) in Upper middle income in 2008 and the Aid flow (current US$) in Kazakhstan in 2010?
Ensure brevity in your answer.  1.28e+08. What is the difference between the Aid flow (current US$) of Cote d'Ivoire in 2008 and the Aid flow (current US$) of Djibouti in 2010?
Give a very brief answer. 1.46e+06. What is the difference between the Aid flow (current US$) in Cote d'Ivoire in 2008 and the Aid flow (current US$) in Kazakhstan in 2010?
Make the answer very short. -2.03e+06. What is the difference between the Aid flow (current US$) of Djibouti in 2008 and the Aid flow (current US$) of Kazakhstan in 2010?
Make the answer very short. -3.51e+06. What is the average Aid flow (current US$) in Upper middle income per year?
Your answer should be compact. 1.20e+08. What is the average Aid flow (current US$) in Cote d'Ivoire per year?
Offer a very short reply. 6.79e+05. What is the average Aid flow (current US$) of Djibouti per year?
Your answer should be very brief. 2.36e+05. What is the average Aid flow (current US$) of Kazakhstan per year?
Your response must be concise. 4.02e+06. In the year 2002, what is the difference between the Aid flow (current US$) in Upper middle income and Aid flow (current US$) in Cote d'Ivoire?
Offer a very short reply. 5.98e+07. In the year 2002, what is the difference between the Aid flow (current US$) of Upper middle income and Aid flow (current US$) of Djibouti?
Your response must be concise. 5.98e+07. In the year 2002, what is the difference between the Aid flow (current US$) in Upper middle income and Aid flow (current US$) in Kazakhstan?
Keep it short and to the point. 4.89e+07. In the year 2002, what is the difference between the Aid flow (current US$) in Cote d'Ivoire and Aid flow (current US$) in Kazakhstan?
Give a very brief answer. -1.09e+07. In the year 2002, what is the difference between the Aid flow (current US$) of Djibouti and Aid flow (current US$) of Kazakhstan?
Offer a very short reply. -1.09e+07. In the year 2003, what is the difference between the Aid flow (current US$) of Upper middle income and Aid flow (current US$) of Cote d'Ivoire?
Keep it short and to the point. 6.96e+07. In the year 2003, what is the difference between the Aid flow (current US$) of Upper middle income and Aid flow (current US$) of Djibouti?
Offer a terse response. 6.97e+07. In the year 2003, what is the difference between the Aid flow (current US$) of Upper middle income and Aid flow (current US$) of Kazakhstan?
Your answer should be compact. 6.73e+07. In the year 2003, what is the difference between the Aid flow (current US$) of Cote d'Ivoire and Aid flow (current US$) of Kazakhstan?
Provide a succinct answer. -2.29e+06. In the year 2003, what is the difference between the Aid flow (current US$) in Djibouti and Aid flow (current US$) in Kazakhstan?
Offer a terse response. -2.38e+06. In the year 2004, what is the difference between the Aid flow (current US$) of Upper middle income and Aid flow (current US$) of Cote d'Ivoire?
Your answer should be compact. 1.19e+08. In the year 2004, what is the difference between the Aid flow (current US$) of Upper middle income and Aid flow (current US$) of Djibouti?
Ensure brevity in your answer.  1.20e+08. In the year 2004, what is the difference between the Aid flow (current US$) in Upper middle income and Aid flow (current US$) in Kazakhstan?
Offer a terse response. 1.17e+08. In the year 2004, what is the difference between the Aid flow (current US$) in Cote d'Ivoire and Aid flow (current US$) in Djibouti?
Keep it short and to the point. 1.00e+05. In the year 2004, what is the difference between the Aid flow (current US$) in Cote d'Ivoire and Aid flow (current US$) in Kazakhstan?
Keep it short and to the point. -2.94e+06. In the year 2004, what is the difference between the Aid flow (current US$) in Djibouti and Aid flow (current US$) in Kazakhstan?
Offer a very short reply. -3.04e+06. In the year 2005, what is the difference between the Aid flow (current US$) of Upper middle income and Aid flow (current US$) of Cote d'Ivoire?
Provide a succinct answer. 1.90e+08. In the year 2005, what is the difference between the Aid flow (current US$) of Upper middle income and Aid flow (current US$) of Djibouti?
Provide a succinct answer. 1.90e+08. In the year 2005, what is the difference between the Aid flow (current US$) in Upper middle income and Aid flow (current US$) in Kazakhstan?
Provide a short and direct response. 1.86e+08. In the year 2005, what is the difference between the Aid flow (current US$) in Cote d'Ivoire and Aid flow (current US$) in Kazakhstan?
Offer a very short reply. -3.42e+06. In the year 2005, what is the difference between the Aid flow (current US$) of Djibouti and Aid flow (current US$) of Kazakhstan?
Give a very brief answer. -3.58e+06. In the year 2006, what is the difference between the Aid flow (current US$) of Upper middle income and Aid flow (current US$) of Cote d'Ivoire?
Provide a succinct answer. 1.30e+08. In the year 2006, what is the difference between the Aid flow (current US$) of Upper middle income and Aid flow (current US$) of Djibouti?
Offer a terse response. 1.31e+08. In the year 2006, what is the difference between the Aid flow (current US$) in Upper middle income and Aid flow (current US$) in Kazakhstan?
Your answer should be compact. 1.28e+08. In the year 2006, what is the difference between the Aid flow (current US$) of Cote d'Ivoire and Aid flow (current US$) of Kazakhstan?
Provide a short and direct response. -1.61e+06. In the year 2006, what is the difference between the Aid flow (current US$) of Djibouti and Aid flow (current US$) of Kazakhstan?
Give a very brief answer. -2.11e+06. In the year 2007, what is the difference between the Aid flow (current US$) of Upper middle income and Aid flow (current US$) of Cote d'Ivoire?
Offer a very short reply. 1.38e+08. In the year 2007, what is the difference between the Aid flow (current US$) of Upper middle income and Aid flow (current US$) of Djibouti?
Ensure brevity in your answer.  1.38e+08. In the year 2007, what is the difference between the Aid flow (current US$) of Upper middle income and Aid flow (current US$) of Kazakhstan?
Your response must be concise. 1.37e+08. In the year 2007, what is the difference between the Aid flow (current US$) of Cote d'Ivoire and Aid flow (current US$) of Djibouti?
Your answer should be compact. 2.80e+05. In the year 2007, what is the difference between the Aid flow (current US$) in Cote d'Ivoire and Aid flow (current US$) in Kazakhstan?
Provide a short and direct response. -1.36e+06. In the year 2007, what is the difference between the Aid flow (current US$) in Djibouti and Aid flow (current US$) in Kazakhstan?
Your answer should be compact. -1.64e+06. In the year 2008, what is the difference between the Aid flow (current US$) in Upper middle income and Aid flow (current US$) in Cote d'Ivoire?
Ensure brevity in your answer.  1.30e+08. In the year 2008, what is the difference between the Aid flow (current US$) of Upper middle income and Aid flow (current US$) of Djibouti?
Offer a very short reply. 1.31e+08. In the year 2008, what is the difference between the Aid flow (current US$) in Upper middle income and Aid flow (current US$) in Kazakhstan?
Keep it short and to the point. 1.28e+08. In the year 2008, what is the difference between the Aid flow (current US$) in Cote d'Ivoire and Aid flow (current US$) in Djibouti?
Offer a very short reply. 1.48e+06. In the year 2008, what is the difference between the Aid flow (current US$) in Cote d'Ivoire and Aid flow (current US$) in Kazakhstan?
Offer a terse response. -1.72e+06. In the year 2008, what is the difference between the Aid flow (current US$) in Djibouti and Aid flow (current US$) in Kazakhstan?
Your answer should be compact. -3.20e+06. In the year 2010, what is the difference between the Aid flow (current US$) in Upper middle income and Aid flow (current US$) in Cote d'Ivoire?
Give a very brief answer. 1.22e+08. In the year 2010, what is the difference between the Aid flow (current US$) in Upper middle income and Aid flow (current US$) in Djibouti?
Give a very brief answer. 1.23e+08. In the year 2010, what is the difference between the Aid flow (current US$) in Upper middle income and Aid flow (current US$) in Kazakhstan?
Provide a succinct answer. 1.20e+08. In the year 2010, what is the difference between the Aid flow (current US$) in Cote d'Ivoire and Aid flow (current US$) in Djibouti?
Offer a terse response. 9.60e+05. In the year 2010, what is the difference between the Aid flow (current US$) of Cote d'Ivoire and Aid flow (current US$) of Kazakhstan?
Ensure brevity in your answer.  -2.53e+06. In the year 2010, what is the difference between the Aid flow (current US$) in Djibouti and Aid flow (current US$) in Kazakhstan?
Your answer should be very brief. -3.49e+06. What is the ratio of the Aid flow (current US$) in Upper middle income in 2002 to that in 2003?
Your answer should be compact. 0.86. What is the ratio of the Aid flow (current US$) of Cote d'Ivoire in 2002 to that in 2003?
Provide a succinct answer. 0.08. What is the ratio of the Aid flow (current US$) in Kazakhstan in 2002 to that in 2003?
Ensure brevity in your answer.  4.51. What is the ratio of the Aid flow (current US$) in Upper middle income in 2002 to that in 2004?
Your answer should be compact. 0.5. What is the ratio of the Aid flow (current US$) of Cote d'Ivoire in 2002 to that in 2004?
Your answer should be very brief. 0.05. What is the ratio of the Aid flow (current US$) of Djibouti in 2002 to that in 2004?
Your answer should be very brief. 0.44. What is the ratio of the Aid flow (current US$) of Kazakhstan in 2002 to that in 2004?
Make the answer very short. 3.49. What is the ratio of the Aid flow (current US$) in Upper middle income in 2002 to that in 2005?
Offer a terse response. 0.32. What is the ratio of the Aid flow (current US$) in Cote d'Ivoire in 2002 to that in 2005?
Offer a terse response. 0.04. What is the ratio of the Aid flow (current US$) in Kazakhstan in 2002 to that in 2005?
Offer a terse response. 2.96. What is the ratio of the Aid flow (current US$) in Upper middle income in 2002 to that in 2006?
Your answer should be very brief. 0.46. What is the ratio of the Aid flow (current US$) in Cote d'Ivoire in 2002 to that in 2006?
Your response must be concise. 0.01. What is the ratio of the Aid flow (current US$) of Djibouti in 2002 to that in 2006?
Offer a very short reply. 0.08. What is the ratio of the Aid flow (current US$) of Kazakhstan in 2002 to that in 2006?
Provide a short and direct response. 4.13. What is the ratio of the Aid flow (current US$) in Upper middle income in 2002 to that in 2007?
Keep it short and to the point. 0.43. What is the ratio of the Aid flow (current US$) of Cote d'Ivoire in 2002 to that in 2007?
Keep it short and to the point. 0.01. What is the ratio of the Aid flow (current US$) in Djibouti in 2002 to that in 2007?
Provide a succinct answer. 0.07. What is the ratio of the Aid flow (current US$) in Kazakhstan in 2002 to that in 2007?
Offer a very short reply. 4.94. What is the ratio of the Aid flow (current US$) of Upper middle income in 2002 to that in 2008?
Provide a succinct answer. 0.46. What is the ratio of the Aid flow (current US$) in Cote d'Ivoire in 2002 to that in 2008?
Make the answer very short. 0.01. What is the ratio of the Aid flow (current US$) in Djibouti in 2002 to that in 2008?
Provide a short and direct response. 0.16. What is the ratio of the Aid flow (current US$) of Kazakhstan in 2002 to that in 2008?
Offer a very short reply. 3.16. What is the ratio of the Aid flow (current US$) in Upper middle income in 2002 to that in 2010?
Offer a terse response. 0.48. What is the ratio of the Aid flow (current US$) in Cote d'Ivoire in 2002 to that in 2010?
Provide a succinct answer. 0.01. What is the ratio of the Aid flow (current US$) in Djibouti in 2002 to that in 2010?
Your answer should be compact. 0.15. What is the ratio of the Aid flow (current US$) of Kazakhstan in 2002 to that in 2010?
Provide a succinct answer. 2.9. What is the ratio of the Aid flow (current US$) in Upper middle income in 2003 to that in 2004?
Give a very brief answer. 0.58. What is the ratio of the Aid flow (current US$) of Cote d'Ivoire in 2003 to that in 2004?
Offer a very short reply. 0.68. What is the ratio of the Aid flow (current US$) in Djibouti in 2003 to that in 2004?
Your answer should be compact. 0.44. What is the ratio of the Aid flow (current US$) of Kazakhstan in 2003 to that in 2004?
Give a very brief answer. 0.77. What is the ratio of the Aid flow (current US$) in Upper middle income in 2003 to that in 2005?
Offer a very short reply. 0.37. What is the ratio of the Aid flow (current US$) in Cote d'Ivoire in 2003 to that in 2005?
Your answer should be compact. 0.5. What is the ratio of the Aid flow (current US$) of Kazakhstan in 2003 to that in 2005?
Ensure brevity in your answer.  0.66. What is the ratio of the Aid flow (current US$) of Upper middle income in 2003 to that in 2006?
Provide a succinct answer. 0.53. What is the ratio of the Aid flow (current US$) of Cote d'Ivoire in 2003 to that in 2006?
Your answer should be compact. 0.13. What is the ratio of the Aid flow (current US$) in Djibouti in 2003 to that in 2006?
Provide a short and direct response. 0.08. What is the ratio of the Aid flow (current US$) of Kazakhstan in 2003 to that in 2006?
Provide a short and direct response. 0.92. What is the ratio of the Aid flow (current US$) of Upper middle income in 2003 to that in 2007?
Your response must be concise. 0.5. What is the ratio of the Aid flow (current US$) in Cote d'Ivoire in 2003 to that in 2007?
Offer a terse response. 0.15. What is the ratio of the Aid flow (current US$) in Djibouti in 2003 to that in 2007?
Offer a terse response. 0.07. What is the ratio of the Aid flow (current US$) in Kazakhstan in 2003 to that in 2007?
Your answer should be very brief. 1.09. What is the ratio of the Aid flow (current US$) in Upper middle income in 2003 to that in 2008?
Your answer should be compact. 0.53. What is the ratio of the Aid flow (current US$) of Cote d'Ivoire in 2003 to that in 2008?
Make the answer very short. 0.08. What is the ratio of the Aid flow (current US$) of Djibouti in 2003 to that in 2008?
Your response must be concise. 0.16. What is the ratio of the Aid flow (current US$) of Kazakhstan in 2003 to that in 2008?
Offer a terse response. 0.7. What is the ratio of the Aid flow (current US$) of Upper middle income in 2003 to that in 2010?
Provide a succinct answer. 0.56. What is the ratio of the Aid flow (current US$) of Cote d'Ivoire in 2003 to that in 2010?
Your answer should be very brief. 0.11. What is the ratio of the Aid flow (current US$) of Djibouti in 2003 to that in 2010?
Give a very brief answer. 0.15. What is the ratio of the Aid flow (current US$) in Kazakhstan in 2003 to that in 2010?
Make the answer very short. 0.64. What is the ratio of the Aid flow (current US$) of Upper middle income in 2004 to that in 2005?
Keep it short and to the point. 0.63. What is the ratio of the Aid flow (current US$) of Cote d'Ivoire in 2004 to that in 2005?
Keep it short and to the point. 0.73. What is the ratio of the Aid flow (current US$) of Djibouti in 2004 to that in 2005?
Your answer should be compact. 0.9. What is the ratio of the Aid flow (current US$) in Kazakhstan in 2004 to that in 2005?
Provide a succinct answer. 0.85. What is the ratio of the Aid flow (current US$) of Upper middle income in 2004 to that in 2006?
Your answer should be very brief. 0.91. What is the ratio of the Aid flow (current US$) in Cote d'Ivoire in 2004 to that in 2006?
Provide a short and direct response. 0.18. What is the ratio of the Aid flow (current US$) in Djibouti in 2004 to that in 2006?
Make the answer very short. 0.17. What is the ratio of the Aid flow (current US$) of Kazakhstan in 2004 to that in 2006?
Make the answer very short. 1.19. What is the ratio of the Aid flow (current US$) of Upper middle income in 2004 to that in 2007?
Keep it short and to the point. 0.86. What is the ratio of the Aid flow (current US$) in Cote d'Ivoire in 2004 to that in 2007?
Offer a terse response. 0.22. What is the ratio of the Aid flow (current US$) in Djibouti in 2004 to that in 2007?
Your answer should be compact. 0.16. What is the ratio of the Aid flow (current US$) of Kazakhstan in 2004 to that in 2007?
Provide a succinct answer. 1.42. What is the ratio of the Aid flow (current US$) in Upper middle income in 2004 to that in 2008?
Your answer should be very brief. 0.91. What is the ratio of the Aid flow (current US$) of Cote d'Ivoire in 2004 to that in 2008?
Keep it short and to the point. 0.11. What is the ratio of the Aid flow (current US$) in Djibouti in 2004 to that in 2008?
Offer a terse response. 0.36. What is the ratio of the Aid flow (current US$) in Kazakhstan in 2004 to that in 2008?
Your answer should be compact. 0.91. What is the ratio of the Aid flow (current US$) of Upper middle income in 2004 to that in 2010?
Your answer should be very brief. 0.97. What is the ratio of the Aid flow (current US$) in Cote d'Ivoire in 2004 to that in 2010?
Your answer should be compact. 0.15. What is the ratio of the Aid flow (current US$) of Kazakhstan in 2004 to that in 2010?
Provide a short and direct response. 0.83. What is the ratio of the Aid flow (current US$) of Upper middle income in 2005 to that in 2006?
Ensure brevity in your answer.  1.45. What is the ratio of the Aid flow (current US$) of Cote d'Ivoire in 2005 to that in 2006?
Your answer should be compact. 0.25. What is the ratio of the Aid flow (current US$) of Djibouti in 2005 to that in 2006?
Ensure brevity in your answer.  0.19. What is the ratio of the Aid flow (current US$) in Kazakhstan in 2005 to that in 2006?
Offer a terse response. 1.39. What is the ratio of the Aid flow (current US$) in Upper middle income in 2005 to that in 2007?
Ensure brevity in your answer.  1.37. What is the ratio of the Aid flow (current US$) in Cote d'Ivoire in 2005 to that in 2007?
Provide a succinct answer. 0.31. What is the ratio of the Aid flow (current US$) of Djibouti in 2005 to that in 2007?
Offer a very short reply. 0.18. What is the ratio of the Aid flow (current US$) in Kazakhstan in 2005 to that in 2007?
Your answer should be very brief. 1.67. What is the ratio of the Aid flow (current US$) in Upper middle income in 2005 to that in 2008?
Give a very brief answer. 1.45. What is the ratio of the Aid flow (current US$) in Cote d'Ivoire in 2005 to that in 2008?
Provide a short and direct response. 0.15. What is the ratio of the Aid flow (current US$) in Djibouti in 2005 to that in 2008?
Keep it short and to the point. 0.4. What is the ratio of the Aid flow (current US$) of Kazakhstan in 2005 to that in 2008?
Keep it short and to the point. 1.07. What is the ratio of the Aid flow (current US$) in Upper middle income in 2005 to that in 2010?
Provide a succinct answer. 1.53. What is the ratio of the Aid flow (current US$) in Cote d'Ivoire in 2005 to that in 2010?
Provide a short and direct response. 0.21. What is the ratio of the Aid flow (current US$) of Djibouti in 2005 to that in 2010?
Provide a short and direct response. 0.37. What is the ratio of the Aid flow (current US$) of Kazakhstan in 2005 to that in 2010?
Offer a very short reply. 0.98. What is the ratio of the Aid flow (current US$) of Upper middle income in 2006 to that in 2007?
Keep it short and to the point. 0.94. What is the ratio of the Aid flow (current US$) in Cote d'Ivoire in 2006 to that in 2007?
Offer a terse response. 1.21. What is the ratio of the Aid flow (current US$) in Djibouti in 2006 to that in 2007?
Keep it short and to the point. 0.93. What is the ratio of the Aid flow (current US$) in Kazakhstan in 2006 to that in 2007?
Give a very brief answer. 1.19. What is the ratio of the Aid flow (current US$) in Cote d'Ivoire in 2006 to that in 2008?
Make the answer very short. 0.6. What is the ratio of the Aid flow (current US$) in Djibouti in 2006 to that in 2008?
Offer a very short reply. 2.12. What is the ratio of the Aid flow (current US$) of Kazakhstan in 2006 to that in 2008?
Offer a terse response. 0.77. What is the ratio of the Aid flow (current US$) of Upper middle income in 2006 to that in 2010?
Your answer should be compact. 1.06. What is the ratio of the Aid flow (current US$) of Cote d'Ivoire in 2006 to that in 2010?
Your answer should be very brief. 0.84. What is the ratio of the Aid flow (current US$) of Djibouti in 2006 to that in 2010?
Keep it short and to the point. 1.96. What is the ratio of the Aid flow (current US$) of Kazakhstan in 2006 to that in 2010?
Provide a succinct answer. 0.7. What is the ratio of the Aid flow (current US$) of Upper middle income in 2007 to that in 2008?
Make the answer very short. 1.06. What is the ratio of the Aid flow (current US$) of Cote d'Ivoire in 2007 to that in 2008?
Offer a terse response. 0.49. What is the ratio of the Aid flow (current US$) of Djibouti in 2007 to that in 2008?
Ensure brevity in your answer.  2.28. What is the ratio of the Aid flow (current US$) of Kazakhstan in 2007 to that in 2008?
Make the answer very short. 0.64. What is the ratio of the Aid flow (current US$) of Upper middle income in 2007 to that in 2010?
Provide a succinct answer. 1.12. What is the ratio of the Aid flow (current US$) of Cote d'Ivoire in 2007 to that in 2010?
Provide a succinct answer. 0.69. What is the ratio of the Aid flow (current US$) of Djibouti in 2007 to that in 2010?
Give a very brief answer. 2.11. What is the ratio of the Aid flow (current US$) in Kazakhstan in 2007 to that in 2010?
Give a very brief answer. 0.59. What is the ratio of the Aid flow (current US$) in Upper middle income in 2008 to that in 2010?
Ensure brevity in your answer.  1.06. What is the ratio of the Aid flow (current US$) of Cote d'Ivoire in 2008 to that in 2010?
Offer a terse response. 1.41. What is the ratio of the Aid flow (current US$) in Djibouti in 2008 to that in 2010?
Keep it short and to the point. 0.93. What is the ratio of the Aid flow (current US$) in Kazakhstan in 2008 to that in 2010?
Provide a short and direct response. 0.92. What is the difference between the highest and the second highest Aid flow (current US$) in Upper middle income?
Your answer should be very brief. 5.10e+07. What is the difference between the highest and the second highest Aid flow (current US$) of Cote d'Ivoire?
Your answer should be compact. 5.00e+05. What is the difference between the highest and the second highest Aid flow (current US$) in Djibouti?
Your answer should be compact. 4.00e+04. What is the difference between the highest and the second highest Aid flow (current US$) of Kazakhstan?
Give a very brief answer. 7.15e+06. What is the difference between the highest and the lowest Aid flow (current US$) in Upper middle income?
Make the answer very short. 1.30e+08. What is the difference between the highest and the lowest Aid flow (current US$) of Cote d'Ivoire?
Your response must be concise. 1.72e+06. What is the difference between the highest and the lowest Aid flow (current US$) of Djibouti?
Offer a very short reply. 5.30e+05. What is the difference between the highest and the lowest Aid flow (current US$) of Kazakhstan?
Ensure brevity in your answer.  8.70e+06. 